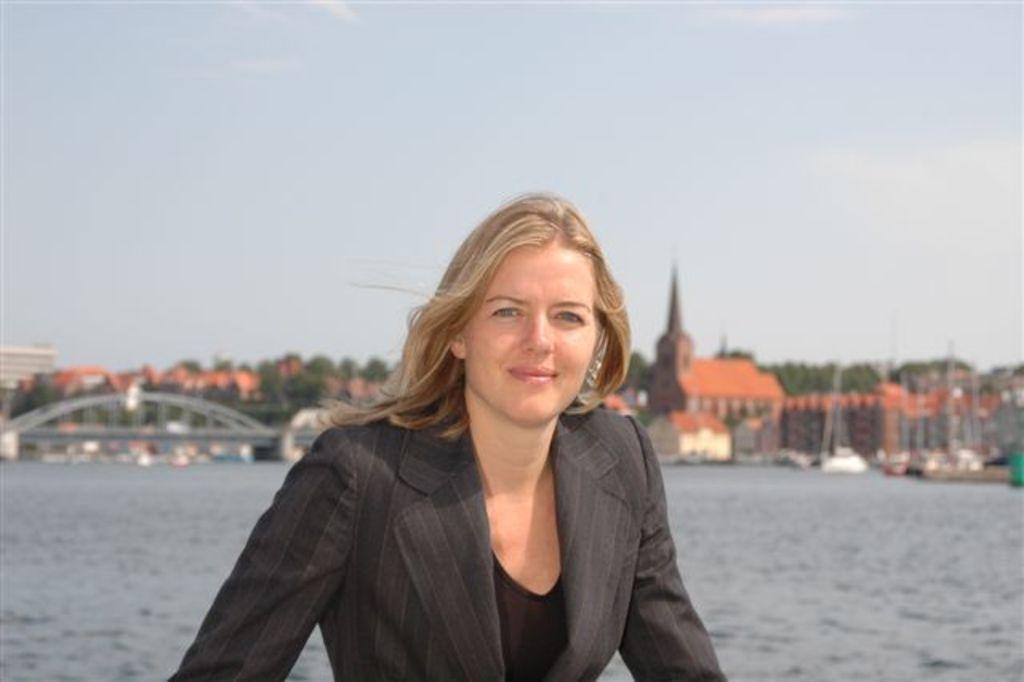Can you describe this image briefly? In the middle of the image a woman is standing and smiling. Behind her there is water and there are some buildings and trees. At the top of the image there are some clouds and sky. 